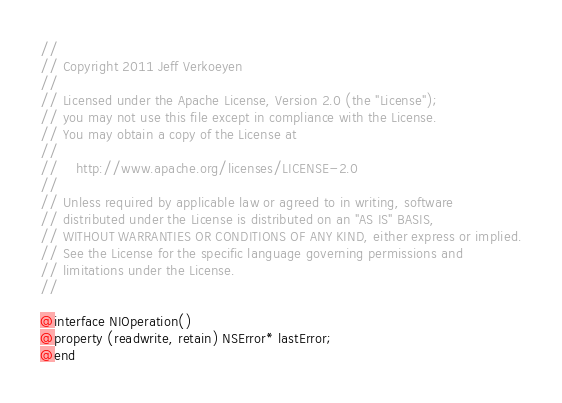<code> <loc_0><loc_0><loc_500><loc_500><_C_>//
// Copyright 2011 Jeff Verkoeyen
//
// Licensed under the Apache License, Version 2.0 (the "License");
// you may not use this file except in compliance with the License.
// You may obtain a copy of the License at
//
//    http://www.apache.org/licenses/LICENSE-2.0
//
// Unless required by applicable law or agreed to in writing, software
// distributed under the License is distributed on an "AS IS" BASIS,
// WITHOUT WARRANTIES OR CONDITIONS OF ANY KIND, either express or implied.
// See the License for the specific language governing permissions and
// limitations under the License.
//

@interface NIOperation()
@property (readwrite, retain) NSError* lastError;
@end
</code> 